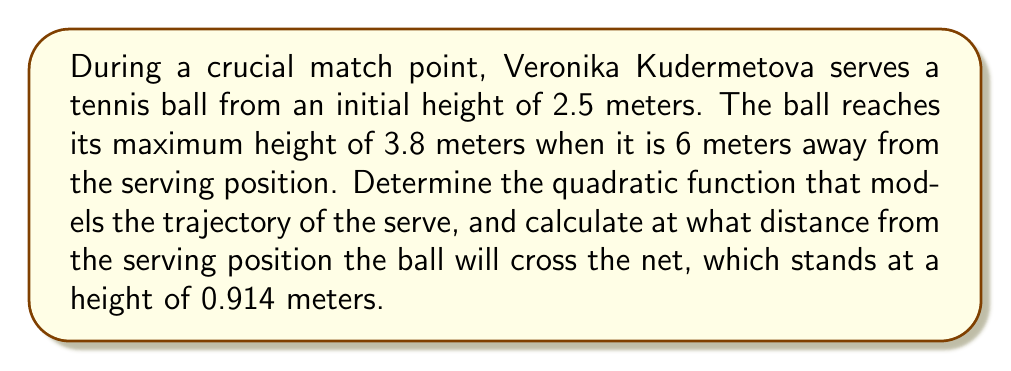Can you answer this question? Let's approach this step-by-step:

1) The general form of a quadratic function is $f(x) = ax^2 + bx + c$, where $a$, $b$, and $c$ are constants and $a \neq 0$.

2) We know three points on this parabola:
   - $(0, 2.5)$: initial position
   - $(6, 3.8)$: maximum height
   - $(x, 0.914)$: where the ball crosses the net (we need to find $x$)

3) Let's start by finding $a$, $b$, and $c$:

   - The y-intercept is 2.5, so $c = 2.5$

   - At the vertex $(6, 3.8)$, the axis of symmetry is $x = 6$. For a parabola, the x-coordinate of the vertex is $-b/(2a)$. So:

     $6 = -b/(2a)$
     $b = -12a$

   - Substituting these into the general form and using the vertex point:

     $3.8 = a(6)^2 + b(6) + 2.5$
     $3.8 = 36a - 72a + 2.5$
     $1.3 = -36a$
     $a = -1.3/36 = -0.03611$

4) Now we have $a$ and can find $b$:

   $b = -12(-0.03611) = 0.43333$

5) Our quadratic function is:

   $f(x) = -0.03611x^2 + 0.43333x + 2.5$

6) To find where the ball crosses the net, we solve:

   $0.914 = -0.03611x^2 + 0.43333x + 2.5$
   $-1.586 = -0.03611x^2 + 0.43333x$
   $0 = 0.03611x^2 - 0.43333x + 1.586$

   Using the quadratic formula, $x = \frac{-b \pm \sqrt{b^2 - 4ac}}{2a}$:

   $x = \frac{0.43333 \pm \sqrt{0.43333^2 - 4(0.03611)(1.586)}}{2(0.03611)}$

   $x \approx 11.97$ or $x \approx 3.03$

   The larger solution (11.97) is the one we want, as the ball crosses the net after reaching its maximum height.
Answer: The quadratic function modeling the trajectory is $f(x) = -0.03611x^2 + 0.43333x + 2.5$, and the ball will cross the net approximately 11.97 meters from the serving position. 